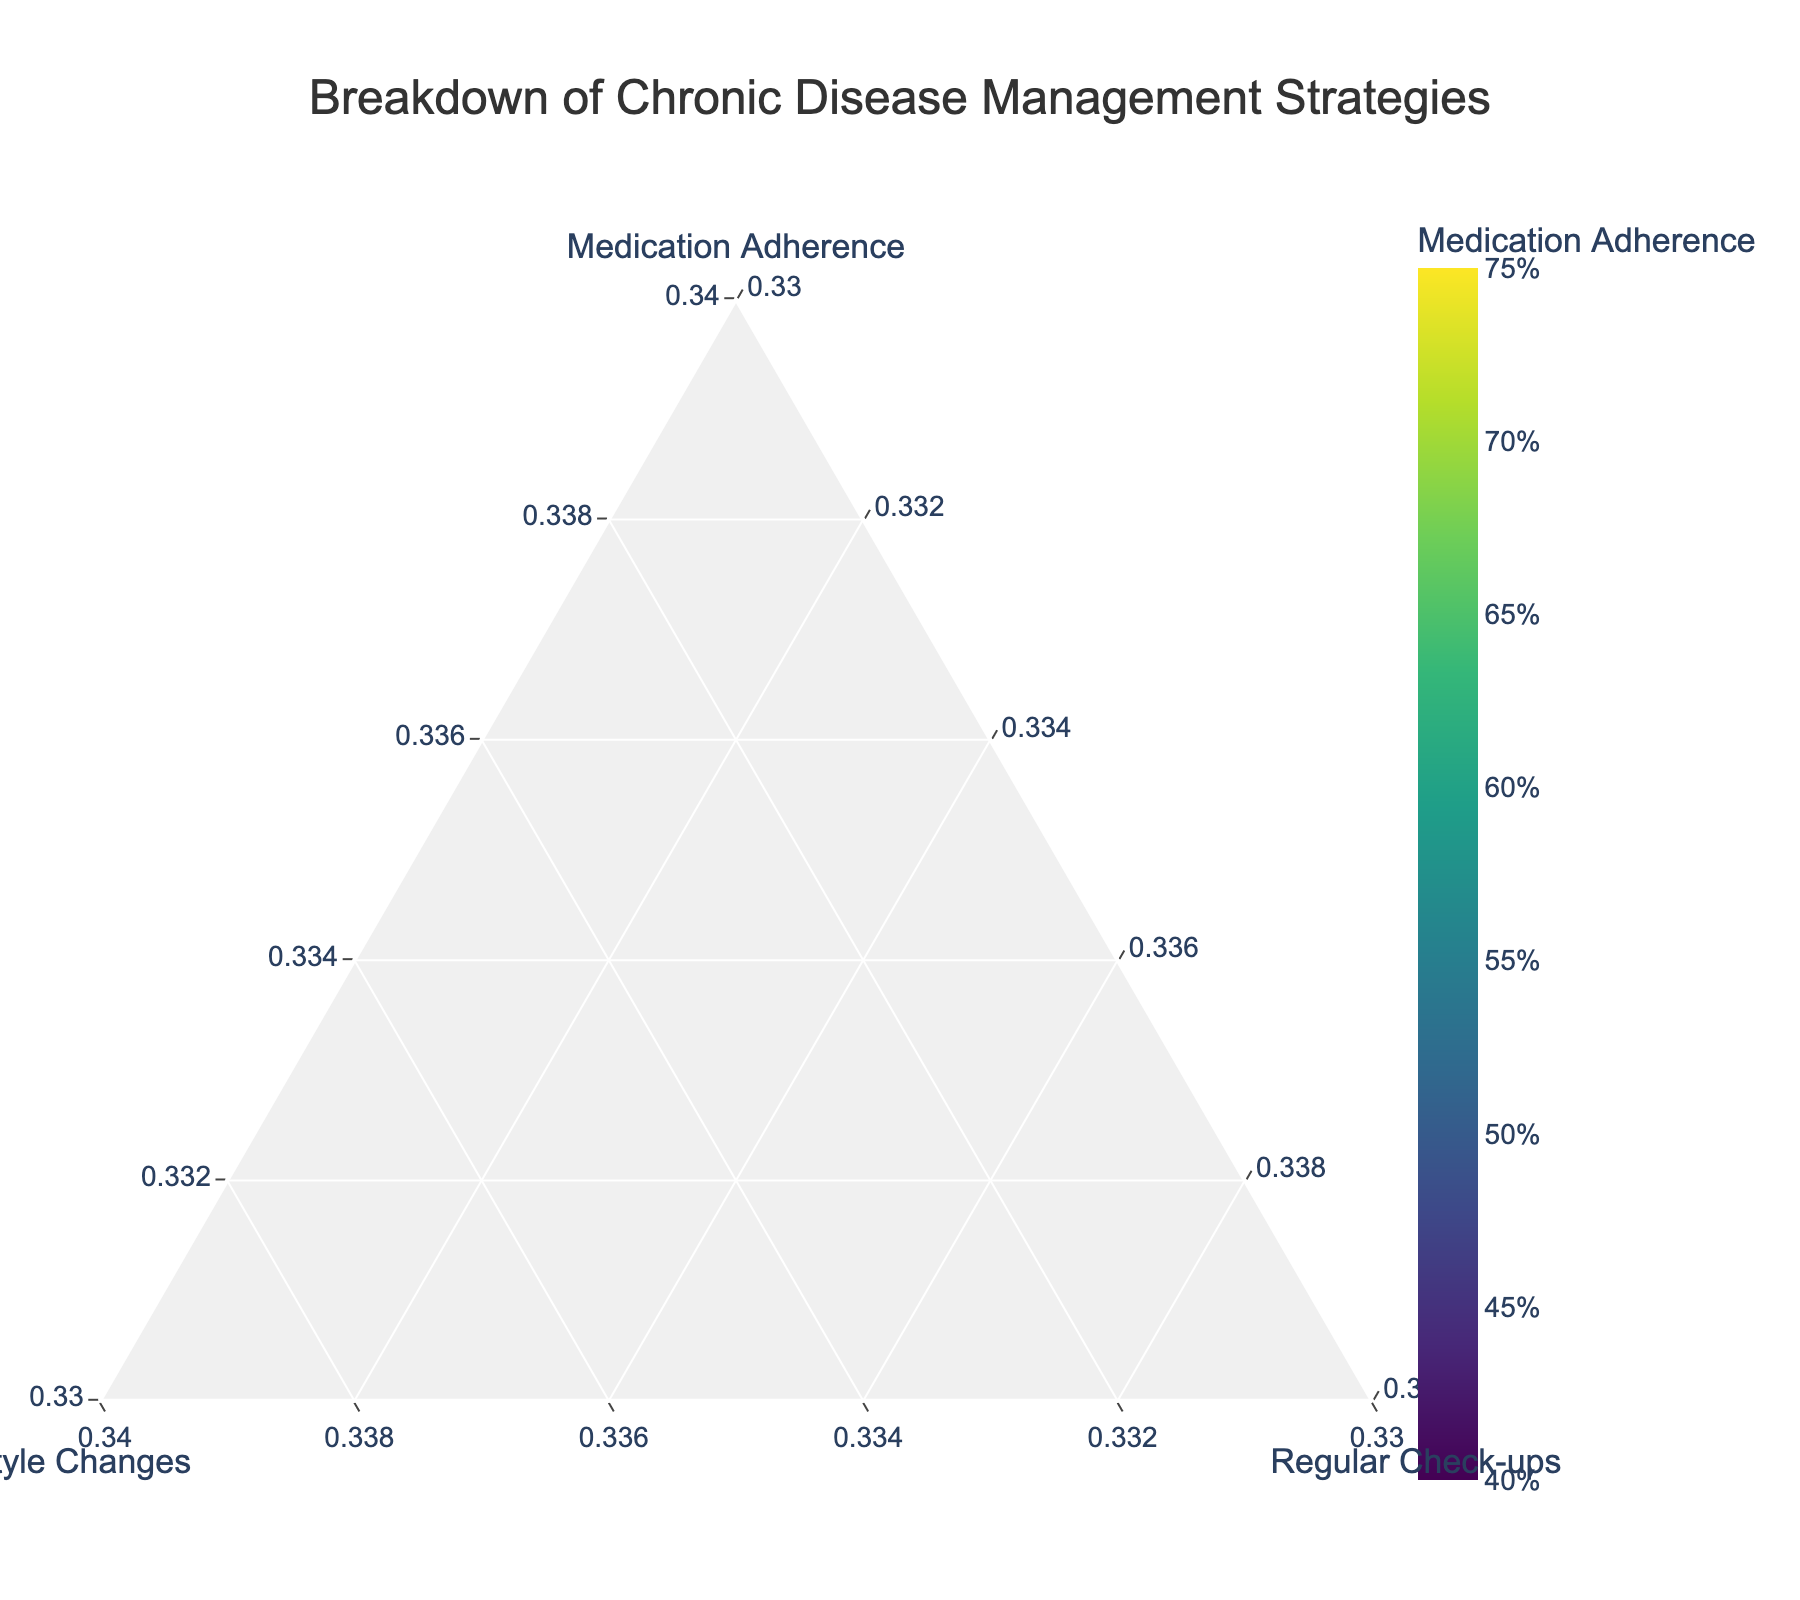Which patient has the highest medication adherence? By examining the figure, see which patient's marker color is the dark shade indicating high medication adherence and check their name label.
Answer: Michael Brown (0.70) and Patricia Clark (0.70) Which patient relies most on lifestyle changes for managing their chronic disease? Look for the marker that is furthest toward the 'Lifestyle Changes' axis, indicating a high proportion allocated to lifestyle changes.
Answer: Robert Taylor (0.45) What is the proportion of regular check-ups for Sarah Davis? Locate Sarah Davis's marker and read the regular check-ups proportion from her hover text in the plot.
Answer: 0.20 Compare the lifestyle change factors between Emily Johnson and Jennifer Lee. Identify the positions of Emily Johnson and Jennifer Lee, then compare their 'Lifestyle Changes' percentages.
Answer: Emily Johnson (0.40) has a higher lifestyle change factor than Jennifer Lee (0.35) Calculate the average medication adherence of all patients. Sum up the medication adherence values for all patients and divide by the number of patients (15). Sum: (0.65 + 0.45 + 0.70 + 0.50 + 0.60 + 0.55 + 0.40 + 0.75 + 0.50 + 0.60 + 0.45 + 0.70 + 0.55 + 0.65 + 0.50) = 8.00. Individual Values Sum: 8.00 / 15 = 0.53
Answer: 0.53 How does the combination of medication adherence and lifestyle changes for Daniel Harris compare to Lisa Anderson? Add the medication adherence and lifestyle changes proportions for both patients and compare the sums: Daniel Harris (0.45 + 0.40) vs. Lisa Anderson (0.75 + 0.15).
Answer: Daniel Harris (0.85) is lower than Lisa Anderson (0.90) Identify which two patients have the same proportion of regular check-ups. Find two patients whose markers have identical positions along the 'Regular Check-ups' axis.
Answer: John Smith and David Wilson (both 0.15) Who has the most balanced approach evenly distributed among the three factors? Look for the marker closest to the center of the ternary plot, indicating an even distribution.
Answer: Sarah Davis (0.50 medication adherence, 0.30 lifestyle changes, 0.20 check-ups) Which data point has the least reliance on regular check-ups? Find the marker closest to the 'Regular Check-ups' corner with the smallest proportion.
Answer: Jennifer Lee (0.10) 